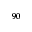<formula> <loc_0><loc_0><loc_500><loc_500>^ { 9 0 }</formula> 